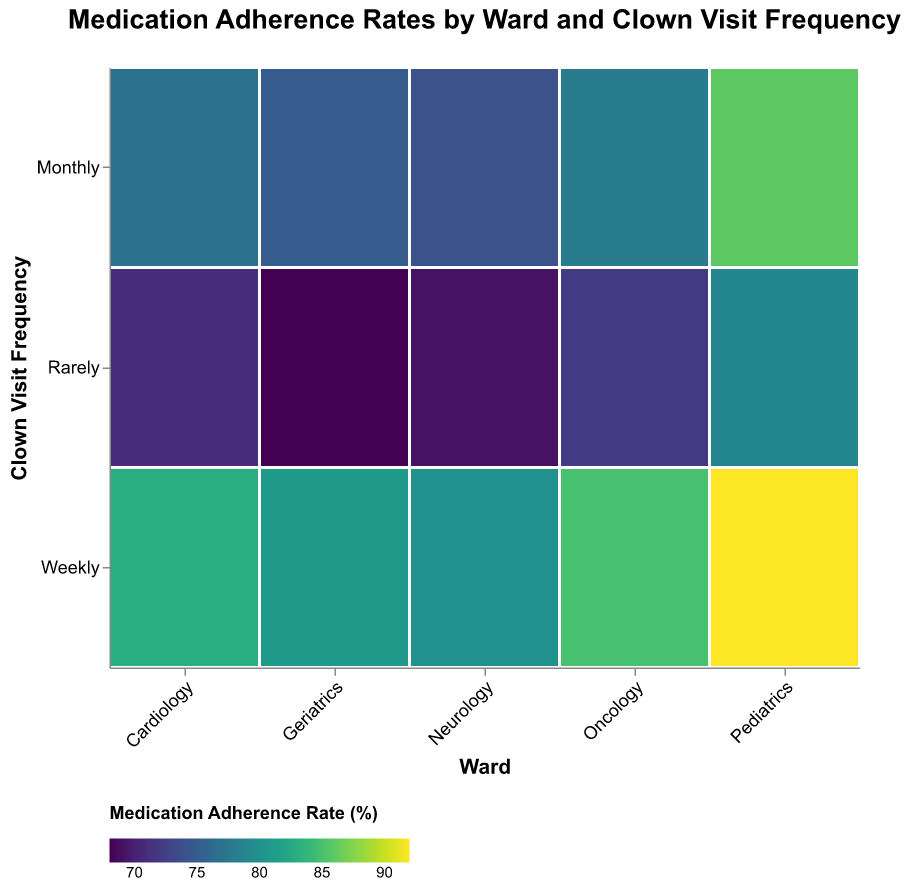What is the title of the mosaic plot? The title is typically located at the top of the plot and provides an overview of what the plot is about. Here, it reads "Medication Adherence Rates by Ward and Clown Visit Frequency."
Answer: Medication Adherence Rates by Ward and Clown Visit Frequency How does medication adherence rate vary in the Oncology ward with different frequencies of clown visits? To answer this question, we need to observe the colors in the Oncology ward row, which correspond to the adherence rates for different clown visit frequencies. Weekly visits show a darker color (indicating a higher adherence rate), followed by monthly, and rarely with the lightest color.
Answer: Weekly is highest, followed by monthly, and rarely is the lowest Which ward has the highest medication adherence rate with weekly clown visits? By comparing the colors in the row for weekly visits among all wards, we see the darkest color in Pediatrics, which indicates the highest adherence rate.
Answer: Pediatrics What can be observed about medication adherence rates between monthly and rarely clown visits in the Geriatrics ward? We compare the colors in the Geriatrics row for monthly and rarely visits. Monthly visits have a darker color than rarely visits, indicating higher adherence rates during monthly visits.
Answer: Monthly visits have a higher adherence rate than rarely visits What is the total number of patients in the ward with the highest medication adherence rate for weekly clown visits? We determined earlier that Pediatrics has the highest adherence rate for weekly visits. Referring to the size of the corresponding rectangle, the patient count here is 150.
Answer: 150 Which clown visit frequency generally shows the lowest medication adherence rates across all wards? By comparing the progression of colors (palette indicating adherence rates) across wards for different visit frequencies, the "Rarely" frequency generally shows the lightest colors, indicating the lowest adherence rates.
Answer: Rarely What is the count difference between Oncology and Cardiology wards for patients with monthly clown visits? We look at the size of rectangles for monthly visits in both Oncology and Cardiology. Oncology has 95 patients, and Cardiology has 105 patients. The difference is 105 - 95 = 10.
Answer: 10 How does medication adherence rate in Pediatrics compare to Geriatrics with weekly clown visits? We compare the color shades for weekly clown visits in Pediatrics and Geriatrics. Pediatrics shows a darker color (higher adherence rate) than Geriatrics.
Answer: Pediatrics has a higher adherence rate Which ward has the most patients during rarely clown visits? We look at the size of the rectangles for rarely visits for all wards. Geriatrics has the largest size, indicating the highest patient count, which is 90.
Answer: Geriatrics What is the relationship between clown visit frequency and medication adherence rate? Observing the general trend in color shades from weekly to monthly to rarely, we see that adherence rates are generally highest with weekly visits, slightly lower with monthly visits, and lowest with rarely visits.
Answer: Higher visit frequency correlates with higher adherence rates 